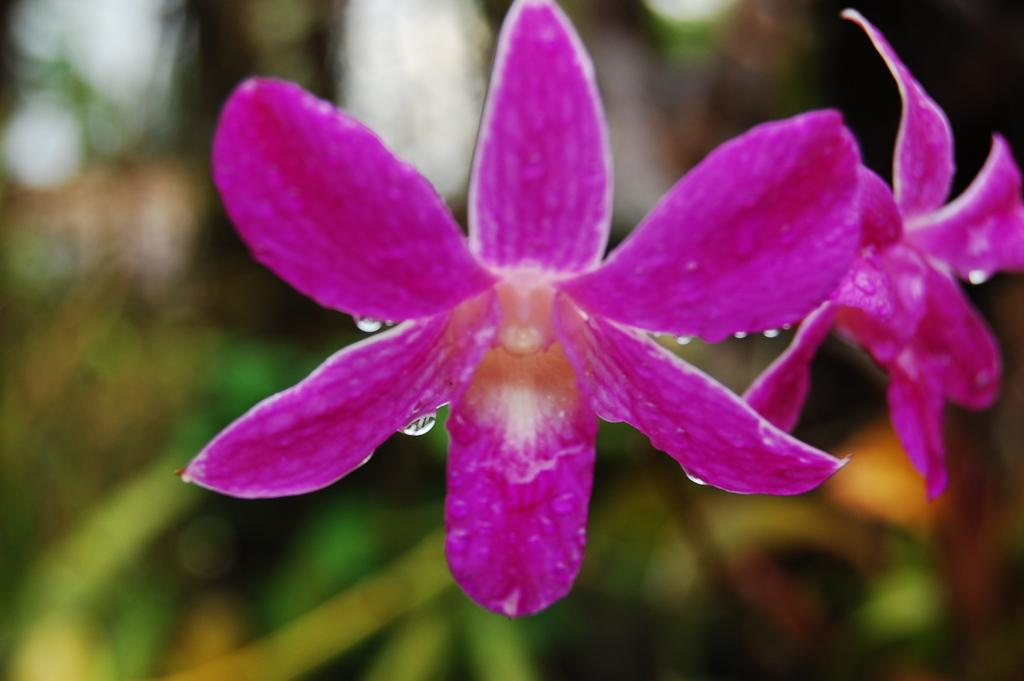What is the main subject of the image? The main subject of the image is a flower. How many pink flowers can be seen on the plant? There are two pink flowers on the plant. Can you describe the quality of the image? The image is blurry at the back. What type of yarn is being used to make the dolls in the image? There are no dolls or yarn present in the image; it is a picture of a flower. How many numbers are visible in the image? There are no numbers visible in the image. 